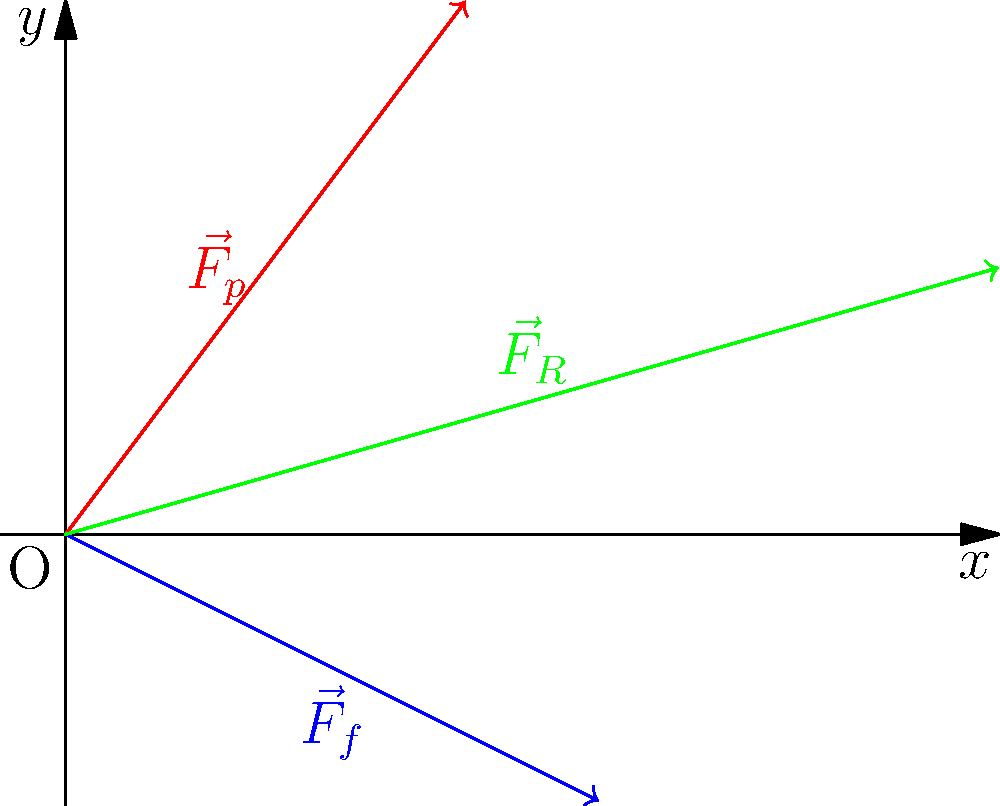In the force vector diagram above, which represents the forces acting on an ice skater during a glide, $\vec{F}_p$ represents the push force, $\vec{F}_f$ represents the friction force, and $\vec{F}_R$ represents the resultant force. What can we conclude about the skater's motion based on this diagram? To analyze the skater's motion, let's break down the force vector diagram step-by-step:

1) The push force $\vec{F}_p$ is directed upward and to the right, indicating the skater's intended direction of motion.

2) The friction force $\vec{F}_f$ is directed downward and to the right, opposing the motion but not directly opposite to the push force due to the low friction of ice.

3) The resultant force $\vec{F}_R$ is the vector sum of $\vec{F}_p$ and $\vec{F}_f$, calculated as:

   $\vec{F}_R = \vec{F}_p + \vec{F}_f$

4) The resultant force $\vec{F}_R$ is pointing to the right and slightly upward, which tells us:
   a) The skater is moving forward (to the right) because the x-component of $\vec{F}_R$ is positive.
   b) There's a small upward component, which might slightly lift the skater or counteract the downward force of gravity.

5) The magnitude of $\vec{F}_R$ is greater than zero, indicating that there is a net force acting on the skater.

6) According to Newton's Second Law of Motion, $\vec{F} = m\vec{a}$, where $\vec{F}$ is the net force, $m$ is mass, and $\vec{a}$ is acceleration.

7) Since $\vec{F}_R \neq 0$, we can conclude that $\vec{a} \neq 0$.

Therefore, based on this force vector diagram, we can conclude that the skater is accelerating forward (to the right) with a slight upward component to their motion.
Answer: The skater is accelerating forward with a slight upward component. 